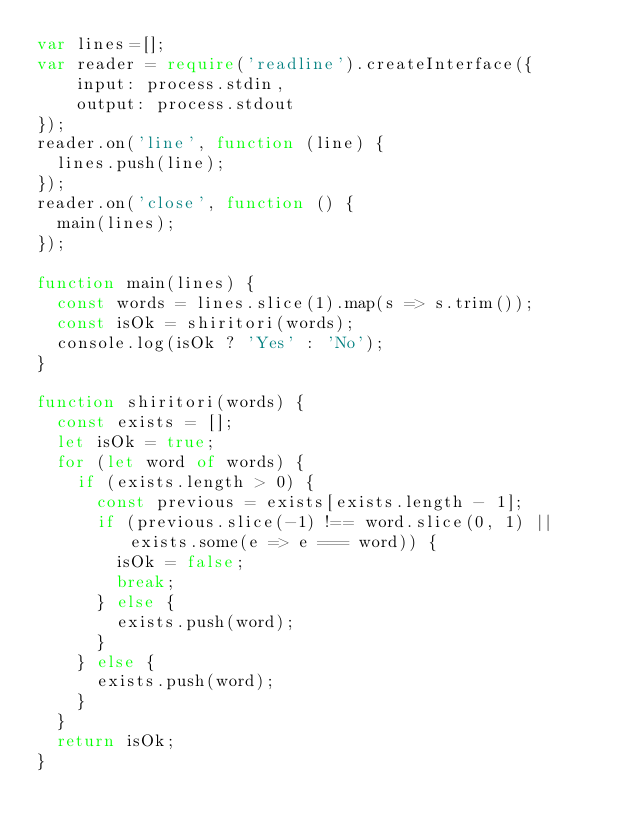<code> <loc_0><loc_0><loc_500><loc_500><_TypeScript_>var lines=[];
var reader = require('readline').createInterface({
    input: process.stdin,
    output: process.stdout
});
reader.on('line', function (line) {
  lines.push(line);
});
reader.on('close', function () {
  main(lines);
});

function main(lines) {
  const words = lines.slice(1).map(s => s.trim());
  const isOk = shiritori(words);
  console.log(isOk ? 'Yes' : 'No'); 
}

function shiritori(words) {
  const exists = [];
  let isOk = true;
  for (let word of words) {
    if (exists.length > 0) {
      const previous = exists[exists.length - 1];
      if (previous.slice(-1) !== word.slice(0, 1) || exists.some(e => e === word)) {
        isOk = false;
        break;
      } else {
        exists.push(word); 
      }
    } else {
      exists.push(word);  
    }
  }
  return isOk;
}
</code> 